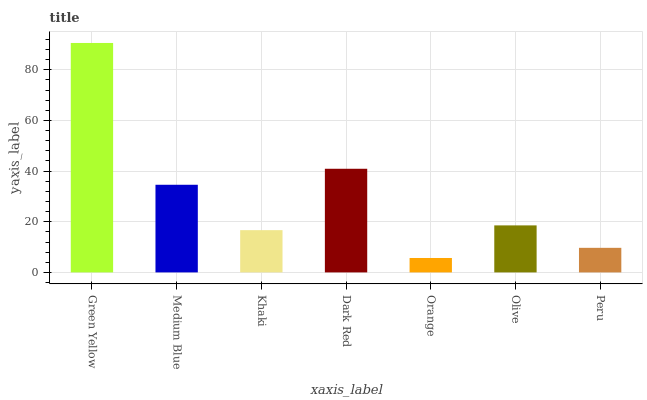Is Orange the minimum?
Answer yes or no. Yes. Is Green Yellow the maximum?
Answer yes or no. Yes. Is Medium Blue the minimum?
Answer yes or no. No. Is Medium Blue the maximum?
Answer yes or no. No. Is Green Yellow greater than Medium Blue?
Answer yes or no. Yes. Is Medium Blue less than Green Yellow?
Answer yes or no. Yes. Is Medium Blue greater than Green Yellow?
Answer yes or no. No. Is Green Yellow less than Medium Blue?
Answer yes or no. No. Is Olive the high median?
Answer yes or no. Yes. Is Olive the low median?
Answer yes or no. Yes. Is Peru the high median?
Answer yes or no. No. Is Khaki the low median?
Answer yes or no. No. 